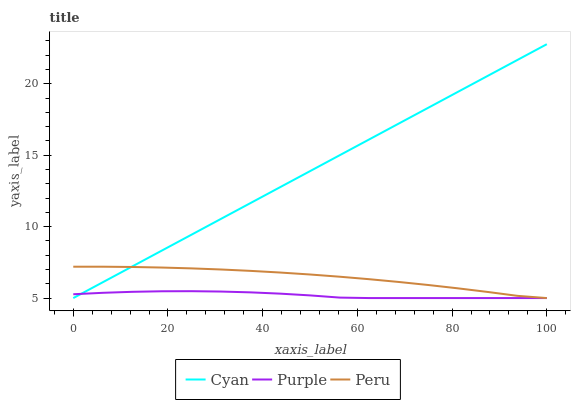Does Purple have the minimum area under the curve?
Answer yes or no. Yes. Does Cyan have the maximum area under the curve?
Answer yes or no. Yes. Does Peru have the minimum area under the curve?
Answer yes or no. No. Does Peru have the maximum area under the curve?
Answer yes or no. No. Is Cyan the smoothest?
Answer yes or no. Yes. Is Purple the roughest?
Answer yes or no. Yes. Is Peru the smoothest?
Answer yes or no. No. Is Peru the roughest?
Answer yes or no. No. Does Purple have the lowest value?
Answer yes or no. Yes. Does Cyan have the highest value?
Answer yes or no. Yes. Does Peru have the highest value?
Answer yes or no. No. Does Peru intersect Cyan?
Answer yes or no. Yes. Is Peru less than Cyan?
Answer yes or no. No. Is Peru greater than Cyan?
Answer yes or no. No. 